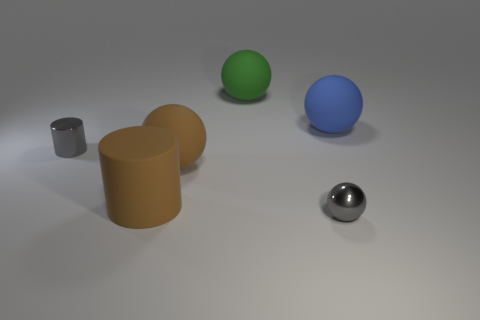What size is the rubber ball that is right of the big sphere that is behind the large blue rubber ball?
Your response must be concise. Large. Does the small metallic cylinder have the same color as the big matte ball in front of the tiny gray shiny cylinder?
Make the answer very short. No. Are there any blue spheres of the same size as the brown cylinder?
Keep it short and to the point. Yes. There is a rubber ball on the right side of the tiny metallic ball; what size is it?
Give a very brief answer. Large. There is a large thing behind the blue sphere; are there any big green objects that are right of it?
Provide a short and direct response. No. What number of other objects are the same shape as the large green object?
Your response must be concise. 3. Does the blue rubber thing have the same shape as the large green thing?
Make the answer very short. Yes. There is a thing that is to the left of the green matte ball and in front of the big brown matte sphere; what is its color?
Ensure brevity in your answer.  Brown. What size is the matte sphere that is the same color as the big rubber cylinder?
Give a very brief answer. Large. How many large objects are green rubber balls or brown metallic objects?
Make the answer very short. 1. 